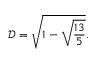Convert formula to latex. <formula><loc_0><loc_0><loc_500><loc_500>\mathcal { D } = \sqrt { 1 - \sqrt { \frac { 1 3 } { 5 } } } .</formula> 